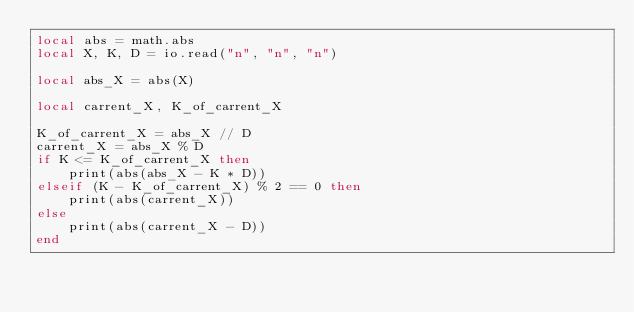Convert code to text. <code><loc_0><loc_0><loc_500><loc_500><_Lua_>local abs = math.abs
local X, K, D = io.read("n", "n", "n")

local abs_X = abs(X)

local carrent_X, K_of_carrent_X

K_of_carrent_X = abs_X // D
carrent_X = abs_X % D
if K <= K_of_carrent_X then
	print(abs(abs_X - K * D))
elseif (K - K_of_carrent_X) % 2 == 0 then
	print(abs(carrent_X))
else
	print(abs(carrent_X - D))
end
</code> 